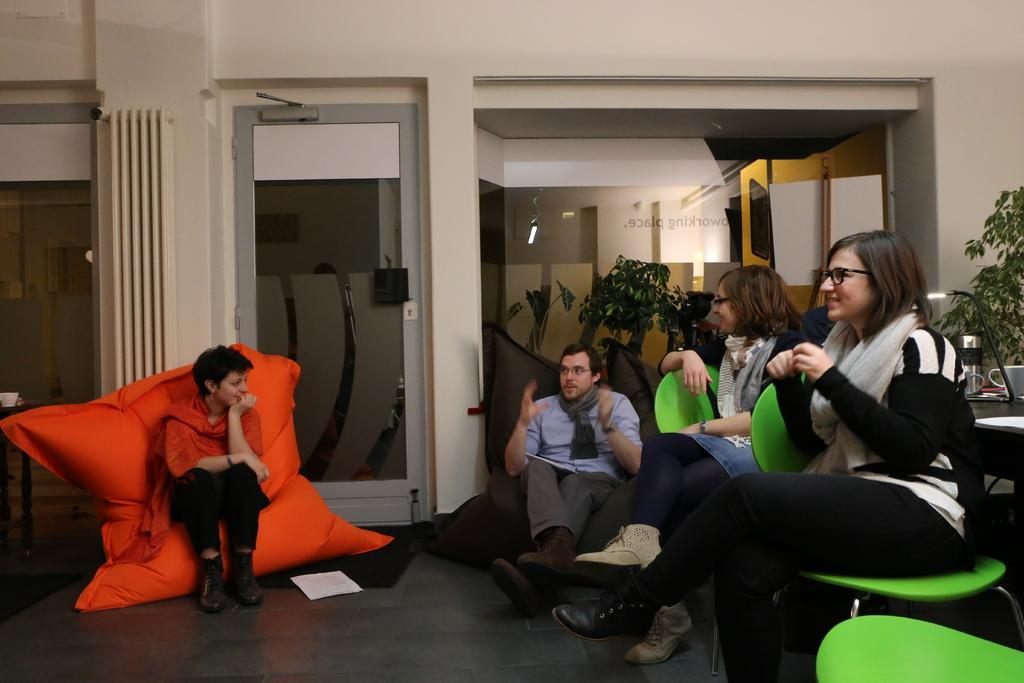What type of furniture can be seen in the image? There are sofas and chairs in the image. How are the people positioned in the image? The people are sitting on sofas and chairs in the image. What can be seen in the background of the image? There is a glass door and a curtain in the background of the image. What type of music is being played by the dog in the image? There is no dog present in the image, and therefore no music being played by a dog. 